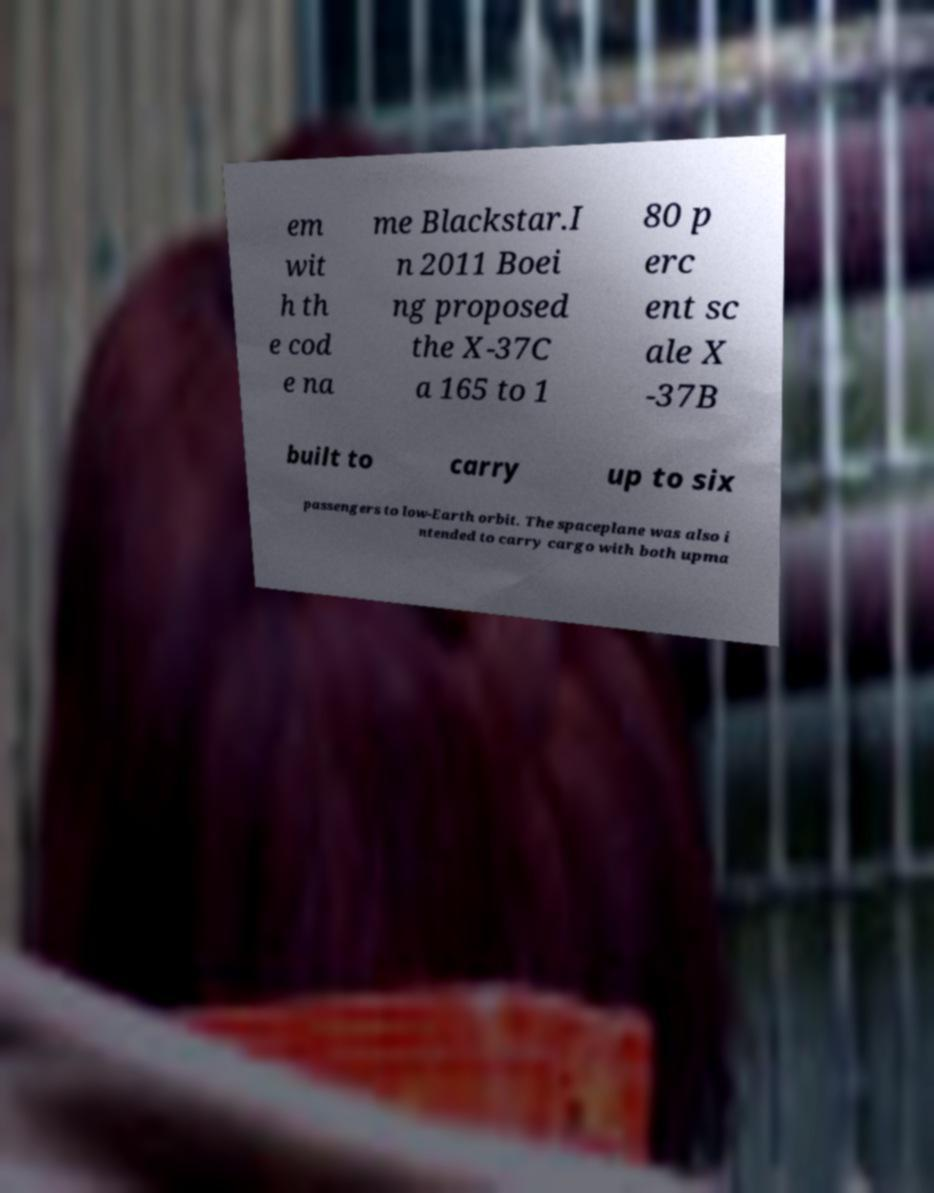Can you read and provide the text displayed in the image?This photo seems to have some interesting text. Can you extract and type it out for me? em wit h th e cod e na me Blackstar.I n 2011 Boei ng proposed the X-37C a 165 to 1 80 p erc ent sc ale X -37B built to carry up to six passengers to low-Earth orbit. The spaceplane was also i ntended to carry cargo with both upma 